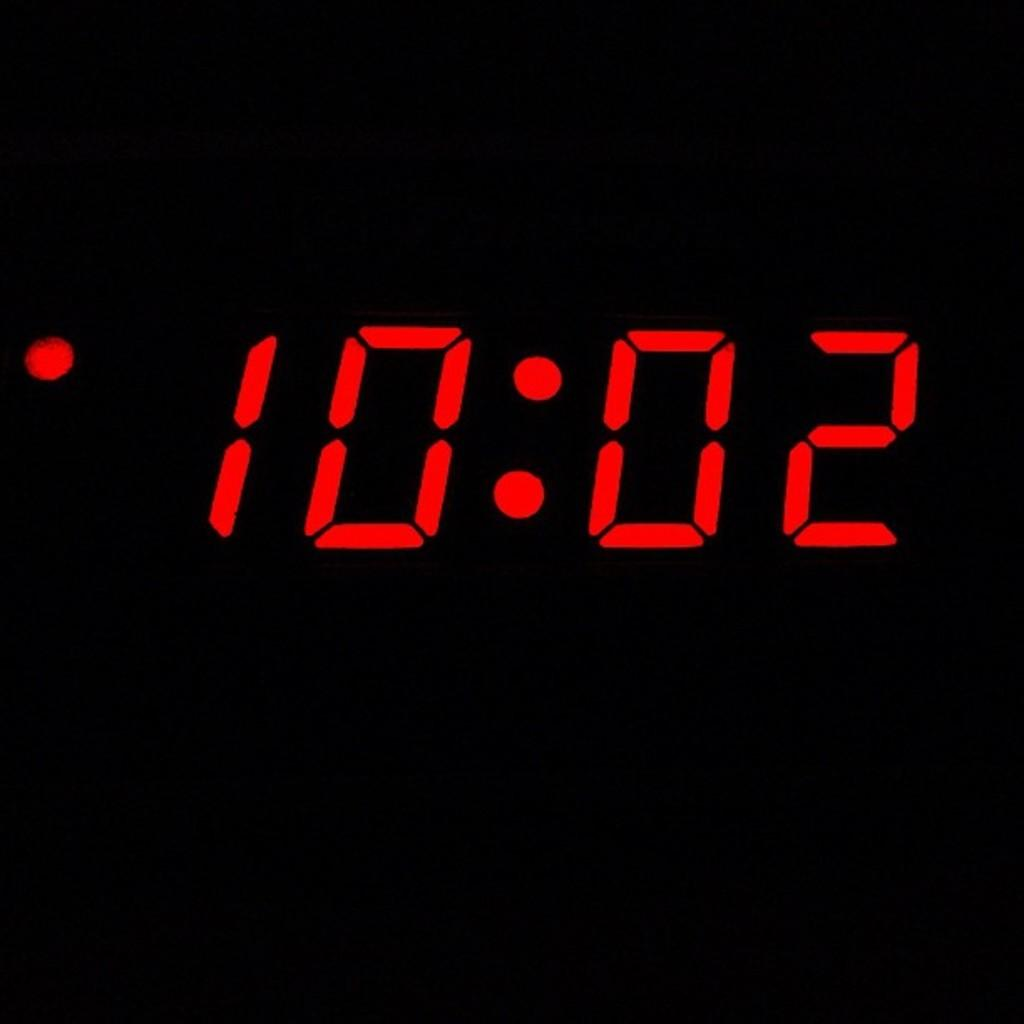<image>
Relay a brief, clear account of the picture shown. The red digital text displays that the time is 10:02. 